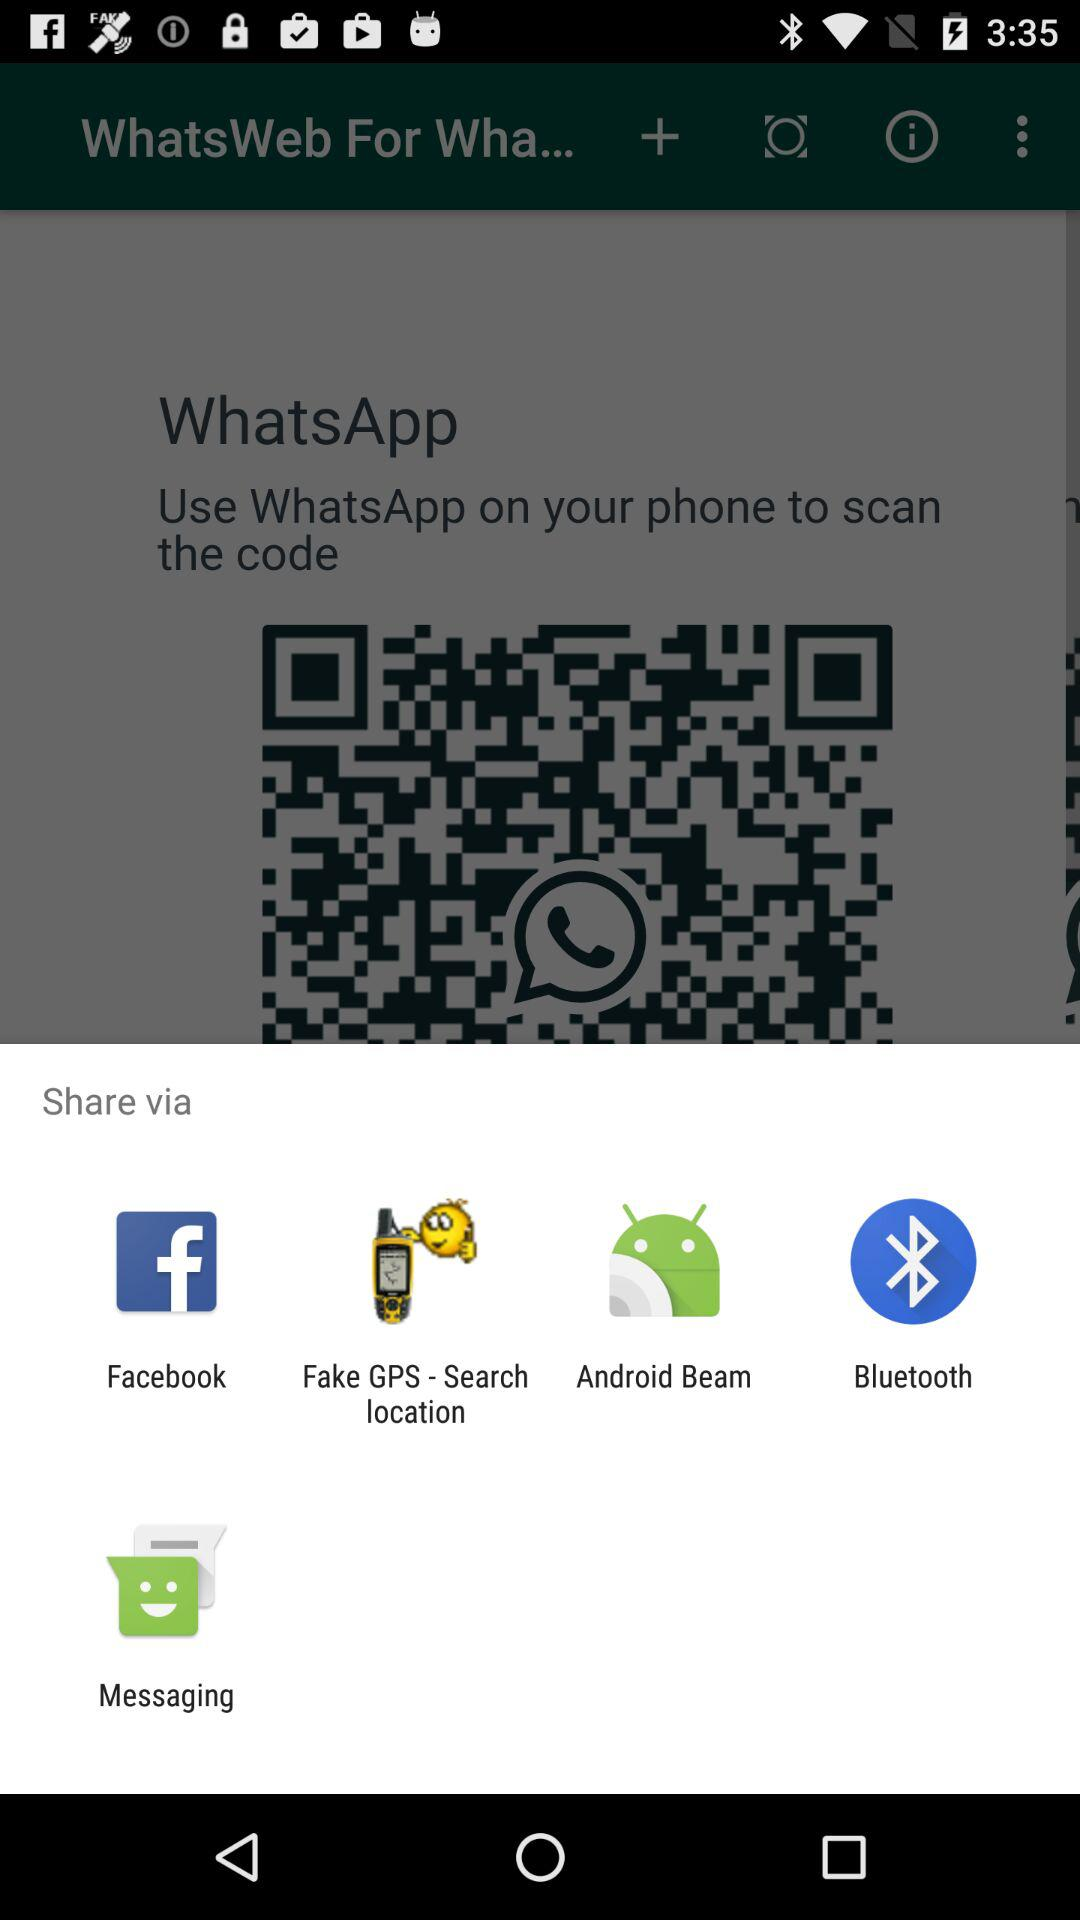Which applications can be used to share? The applications that can be used to share are "Facebook", "Fake GPS - Search location", "Android Beam", "Bluetooth" and "Messaging". 